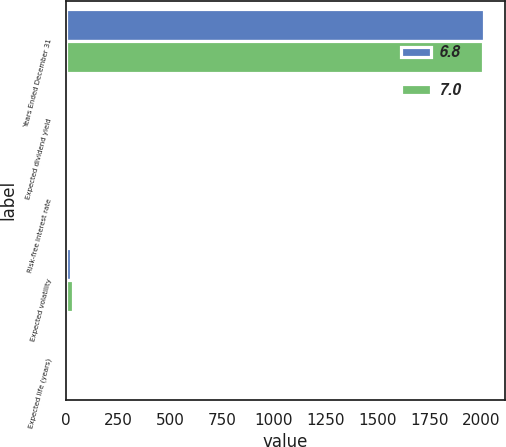Convert chart to OTSL. <chart><loc_0><loc_0><loc_500><loc_500><stacked_bar_chart><ecel><fcel>Years Ended December 31<fcel>Expected dividend yield<fcel>Risk-free interest rate<fcel>Expected volatility<fcel>Expected life (years)<nl><fcel>6.8<fcel>2012<fcel>4.4<fcel>1.3<fcel>25.2<fcel>7<nl><fcel>7<fcel>2010<fcel>4.1<fcel>2.8<fcel>33.7<fcel>6.8<nl></chart> 